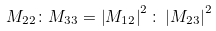Convert formula to latex. <formula><loc_0><loc_0><loc_500><loc_500>M _ { 2 2 } \colon M _ { 3 3 } = \left | M _ { 1 2 } \right | ^ { 2 } \colon \left | M _ { 2 3 } \right | ^ { 2 }</formula> 